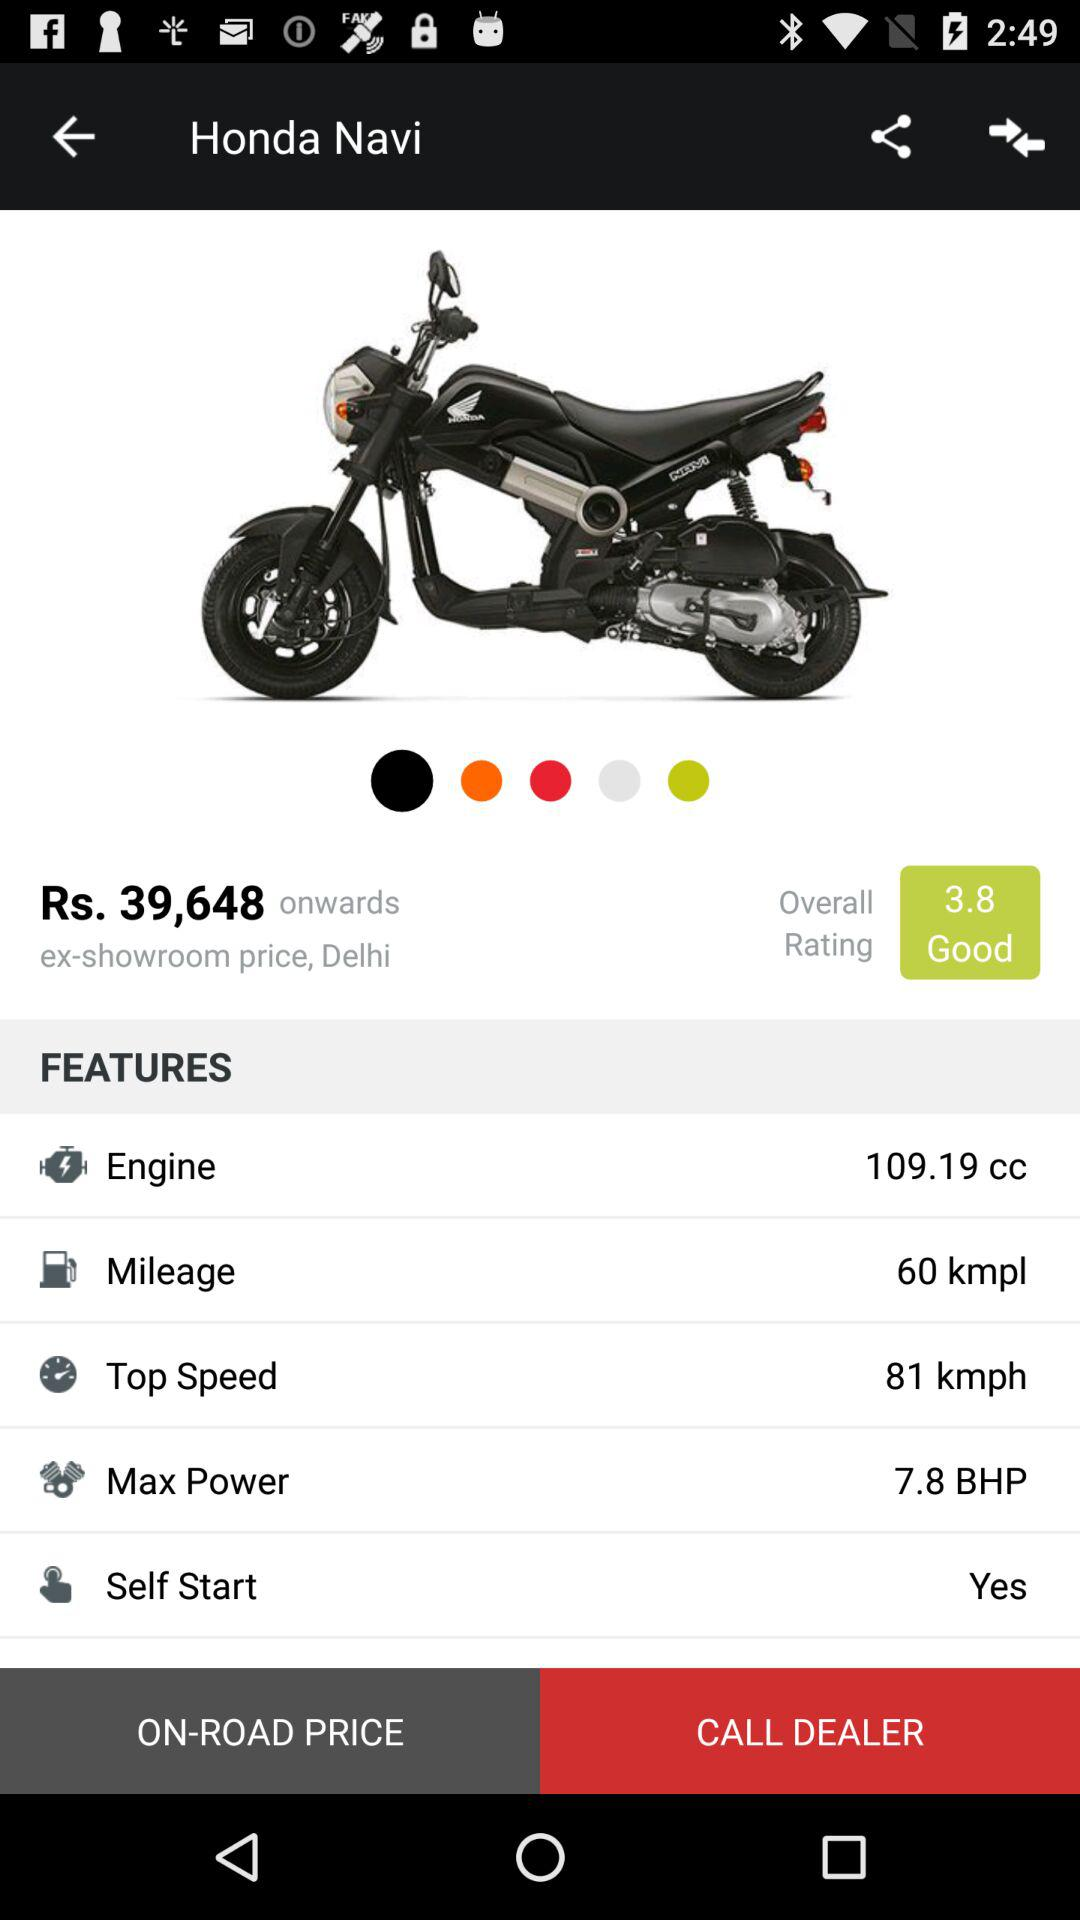What is the highest speed of Honda Navi?
Answer the question using a single word or phrase. 81 kmph 